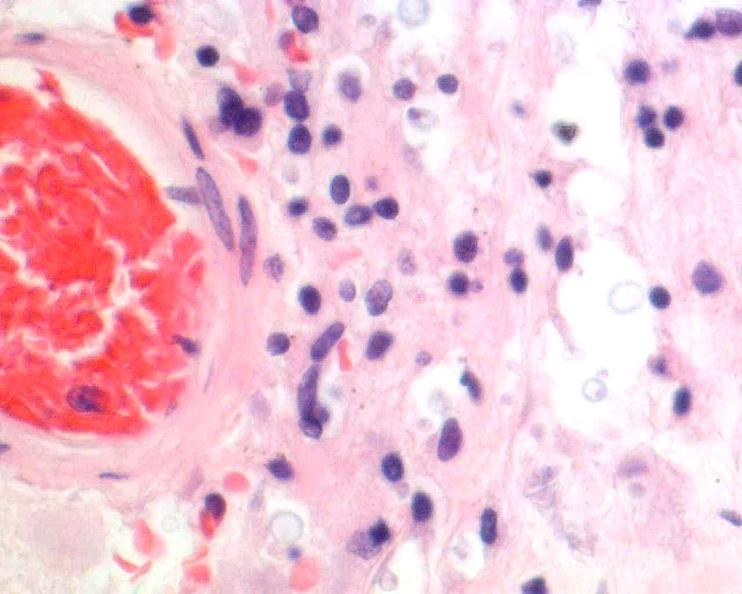what does this image show?
Answer the question using a single word or phrase. Brain 